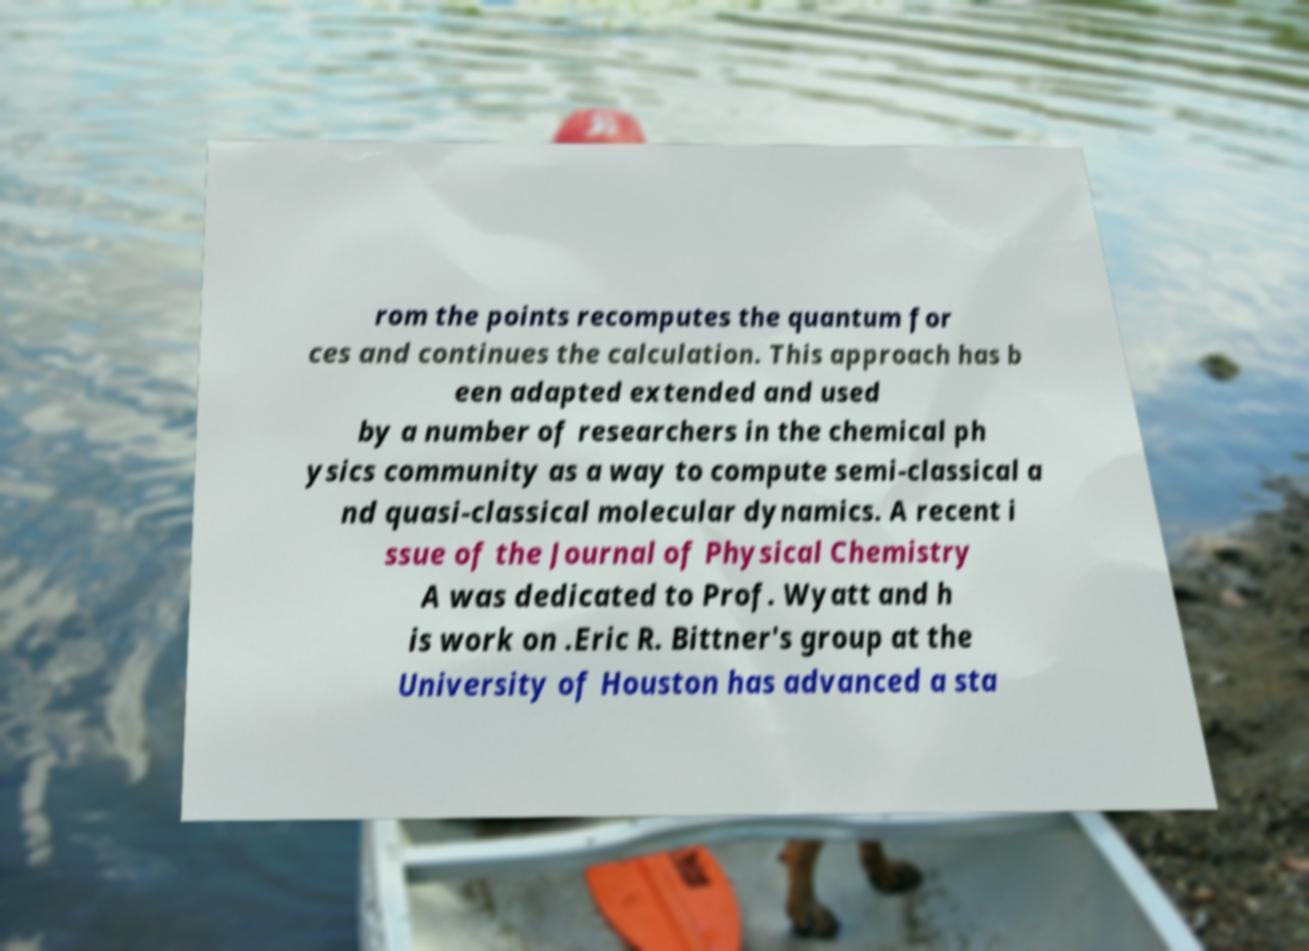Can you accurately transcribe the text from the provided image for me? rom the points recomputes the quantum for ces and continues the calculation. This approach has b een adapted extended and used by a number of researchers in the chemical ph ysics community as a way to compute semi-classical a nd quasi-classical molecular dynamics. A recent i ssue of the Journal of Physical Chemistry A was dedicated to Prof. Wyatt and h is work on .Eric R. Bittner's group at the University of Houston has advanced a sta 